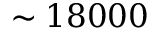Convert formula to latex. <formula><loc_0><loc_0><loc_500><loc_500>\sim 1 8 0 0 0</formula> 